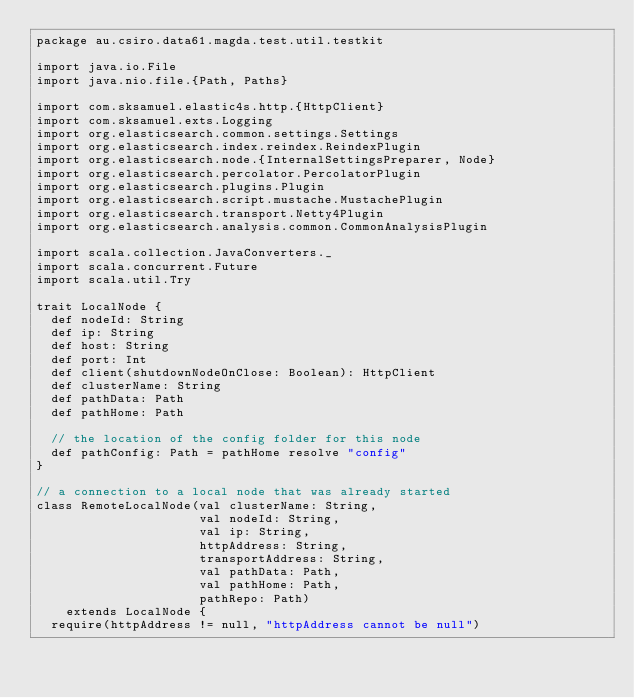Convert code to text. <code><loc_0><loc_0><loc_500><loc_500><_Scala_>package au.csiro.data61.magda.test.util.testkit

import java.io.File
import java.nio.file.{Path, Paths}

import com.sksamuel.elastic4s.http.{HttpClient}
import com.sksamuel.exts.Logging
import org.elasticsearch.common.settings.Settings
import org.elasticsearch.index.reindex.ReindexPlugin
import org.elasticsearch.node.{InternalSettingsPreparer, Node}
import org.elasticsearch.percolator.PercolatorPlugin
import org.elasticsearch.plugins.Plugin
import org.elasticsearch.script.mustache.MustachePlugin
import org.elasticsearch.transport.Netty4Plugin
import org.elasticsearch.analysis.common.CommonAnalysisPlugin

import scala.collection.JavaConverters._
import scala.concurrent.Future
import scala.util.Try

trait LocalNode {
  def nodeId: String
  def ip: String
  def host: String
  def port: Int
  def client(shutdownNodeOnClose: Boolean): HttpClient
  def clusterName: String
  def pathData: Path
  def pathHome: Path

  // the location of the config folder for this node
  def pathConfig: Path = pathHome resolve "config"
}

// a connection to a local node that was already started
class RemoteLocalNode(val clusterName: String,
                      val nodeId: String,
                      val ip: String,
                      httpAddress: String,
                      transportAddress: String,
                      val pathData: Path,
                      val pathHome: Path,
                      pathRepo: Path)
    extends LocalNode {
  require(httpAddress != null, "httpAddress cannot be null")</code> 